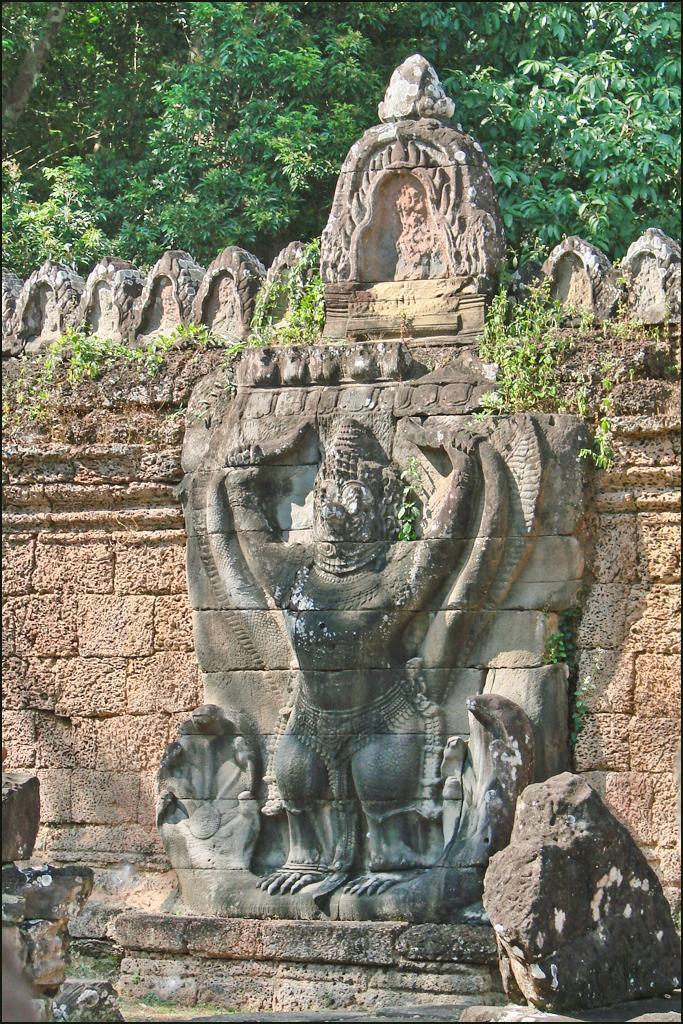How would you summarize this image in a sentence or two? In this image, we can see some sculpture on the wall. There is a stone at the bottom of the image. Here we can see few plants. Top of the image, we can see trees. 